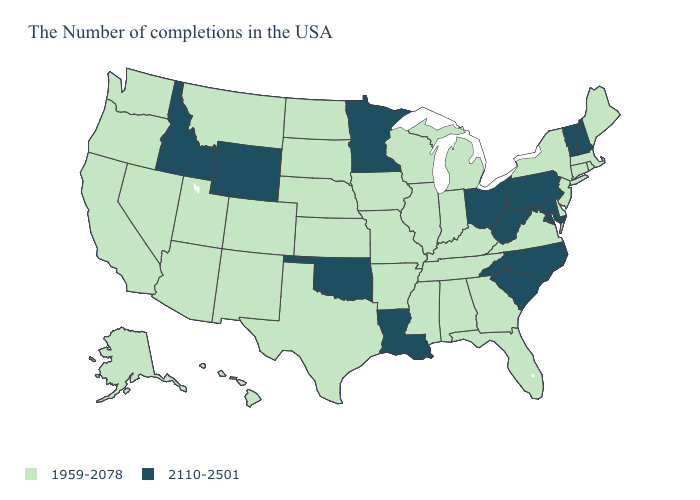What is the value of Arkansas?
Give a very brief answer. 1959-2078. Name the states that have a value in the range 2110-2501?
Answer briefly. New Hampshire, Vermont, Maryland, Pennsylvania, North Carolina, South Carolina, West Virginia, Ohio, Louisiana, Minnesota, Oklahoma, Wyoming, Idaho. Name the states that have a value in the range 1959-2078?
Give a very brief answer. Maine, Massachusetts, Rhode Island, Connecticut, New York, New Jersey, Delaware, Virginia, Florida, Georgia, Michigan, Kentucky, Indiana, Alabama, Tennessee, Wisconsin, Illinois, Mississippi, Missouri, Arkansas, Iowa, Kansas, Nebraska, Texas, South Dakota, North Dakota, Colorado, New Mexico, Utah, Montana, Arizona, Nevada, California, Washington, Oregon, Alaska, Hawaii. What is the value of Wisconsin?
Give a very brief answer. 1959-2078. Name the states that have a value in the range 2110-2501?
Short answer required. New Hampshire, Vermont, Maryland, Pennsylvania, North Carolina, South Carolina, West Virginia, Ohio, Louisiana, Minnesota, Oklahoma, Wyoming, Idaho. What is the value of South Carolina?
Short answer required. 2110-2501. Does New York have the highest value in the USA?
Write a very short answer. No. Name the states that have a value in the range 2110-2501?
Short answer required. New Hampshire, Vermont, Maryland, Pennsylvania, North Carolina, South Carolina, West Virginia, Ohio, Louisiana, Minnesota, Oklahoma, Wyoming, Idaho. What is the value of Maryland?
Keep it brief. 2110-2501. Does Virginia have a lower value than West Virginia?
Keep it brief. Yes. What is the value of Illinois?
Be succinct. 1959-2078. What is the value of Minnesota?
Short answer required. 2110-2501. What is the highest value in states that border Iowa?
Write a very short answer. 2110-2501. What is the value of Nebraska?
Answer briefly. 1959-2078. 